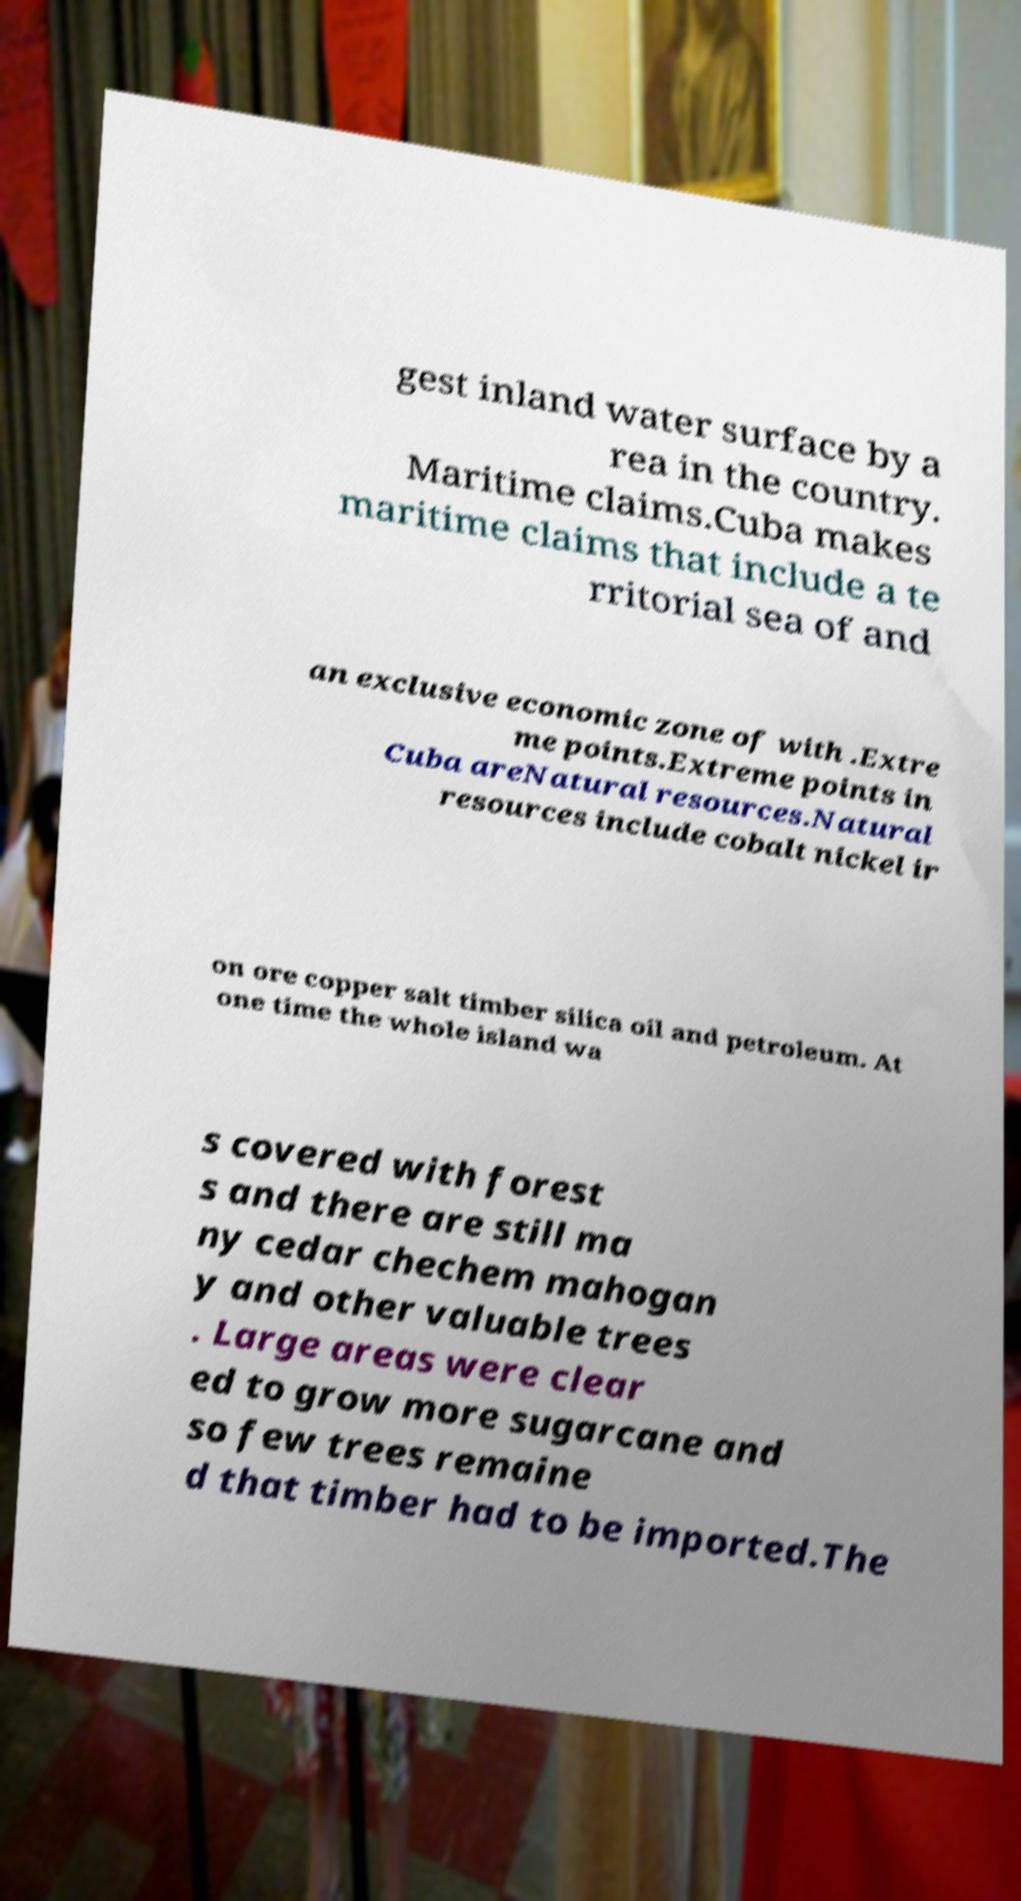What messages or text are displayed in this image? I need them in a readable, typed format. gest inland water surface by a rea in the country. Maritime claims.Cuba makes maritime claims that include a te rritorial sea of and an exclusive economic zone of with .Extre me points.Extreme points in Cuba areNatural resources.Natural resources include cobalt nickel ir on ore copper salt timber silica oil and petroleum. At one time the whole island wa s covered with forest s and there are still ma ny cedar chechem mahogan y and other valuable trees . Large areas were clear ed to grow more sugarcane and so few trees remaine d that timber had to be imported.The 